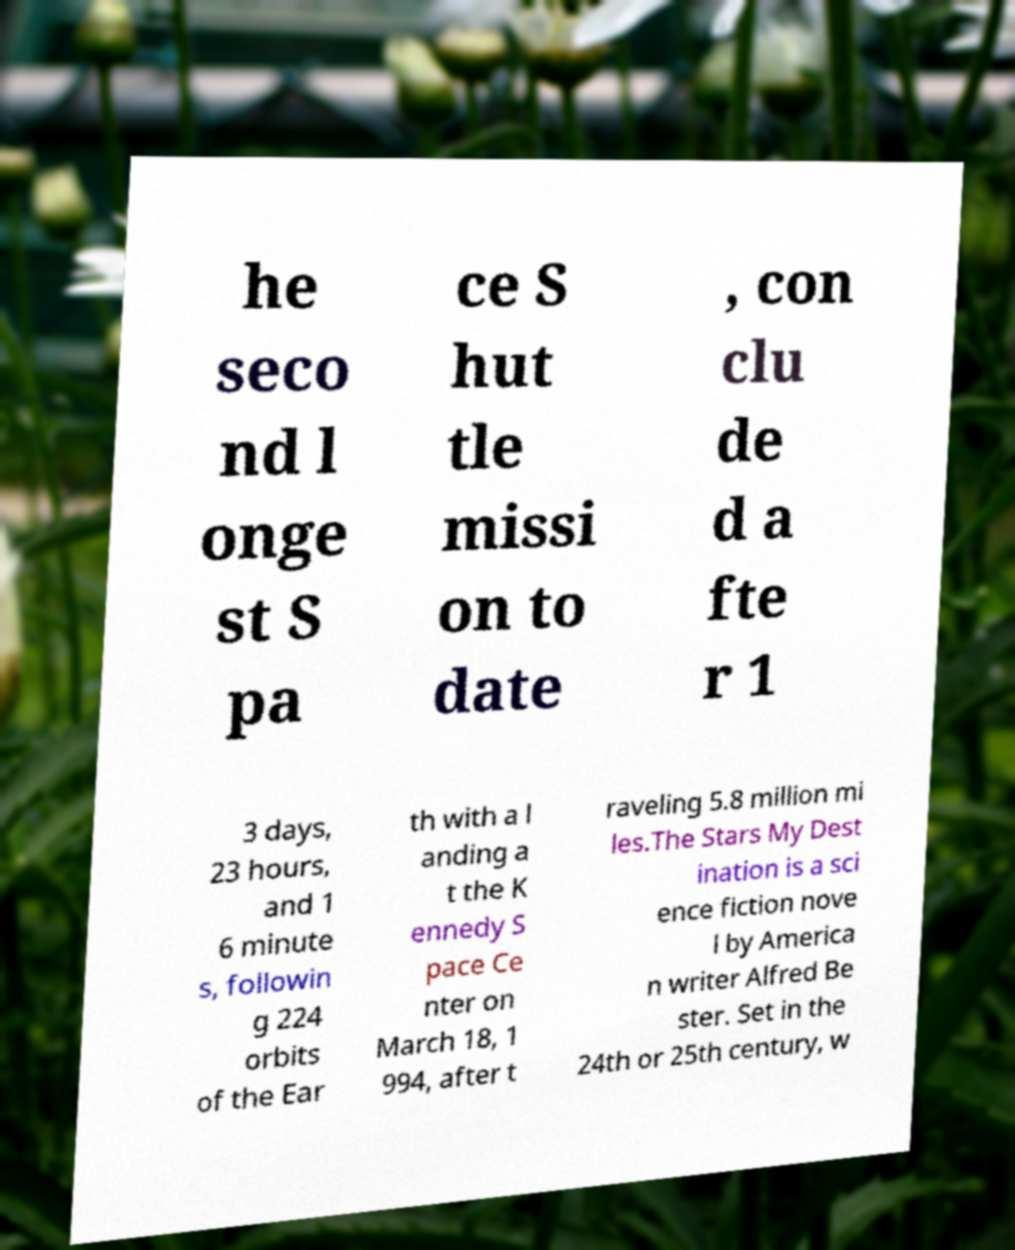For documentation purposes, I need the text within this image transcribed. Could you provide that? he seco nd l onge st S pa ce S hut tle missi on to date , con clu de d a fte r 1 3 days, 23 hours, and 1 6 minute s, followin g 224 orbits of the Ear th with a l anding a t the K ennedy S pace Ce nter on March 18, 1 994, after t raveling 5.8 million mi les.The Stars My Dest ination is a sci ence fiction nove l by America n writer Alfred Be ster. Set in the 24th or 25th century, w 